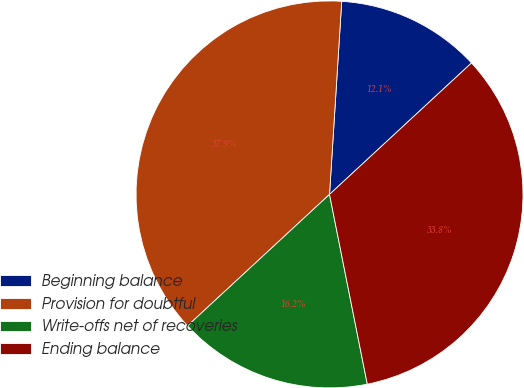<chart> <loc_0><loc_0><loc_500><loc_500><pie_chart><fcel>Beginning balance<fcel>Provision for doubtful<fcel>Write-offs net of recoveries<fcel>Ending balance<nl><fcel>12.11%<fcel>37.89%<fcel>16.24%<fcel>33.76%<nl></chart> 